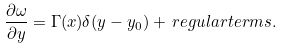<formula> <loc_0><loc_0><loc_500><loc_500>\frac { \partial \omega } { \partial y } = \Gamma ( x ) \delta ( y - y _ { 0 } ) + \, r e g u l a r t e r m s .</formula> 